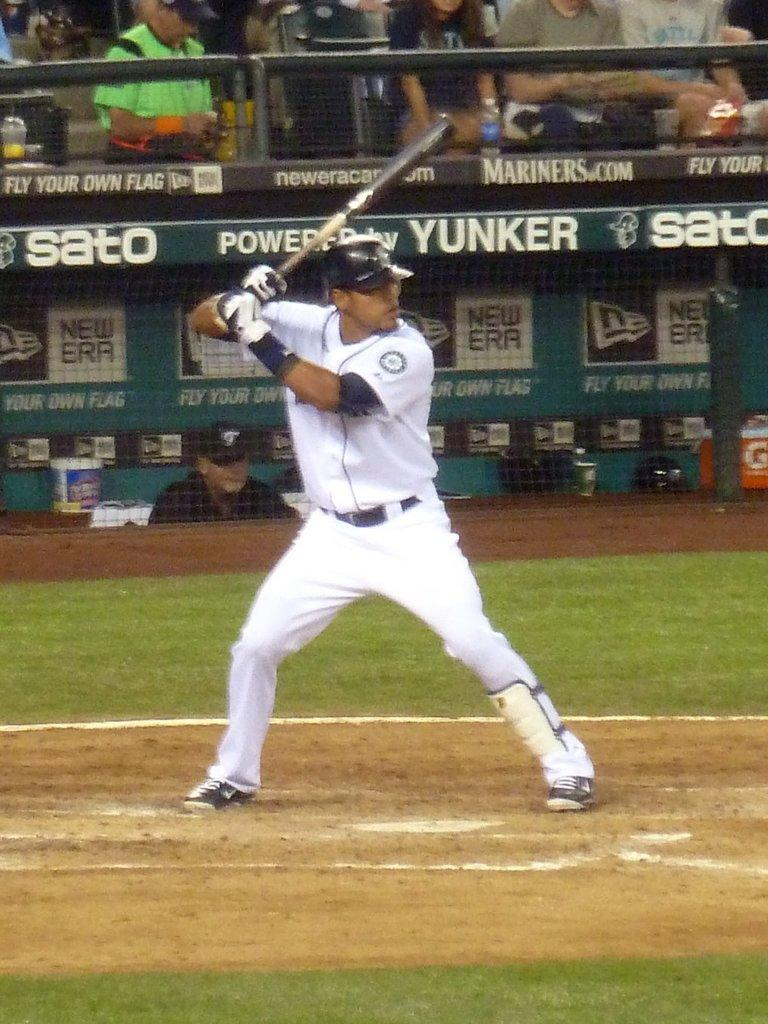<image>
Create a compact narrative representing the image presented. A baseball player is swinging a bat in front of an advertisement that says Yunker. 